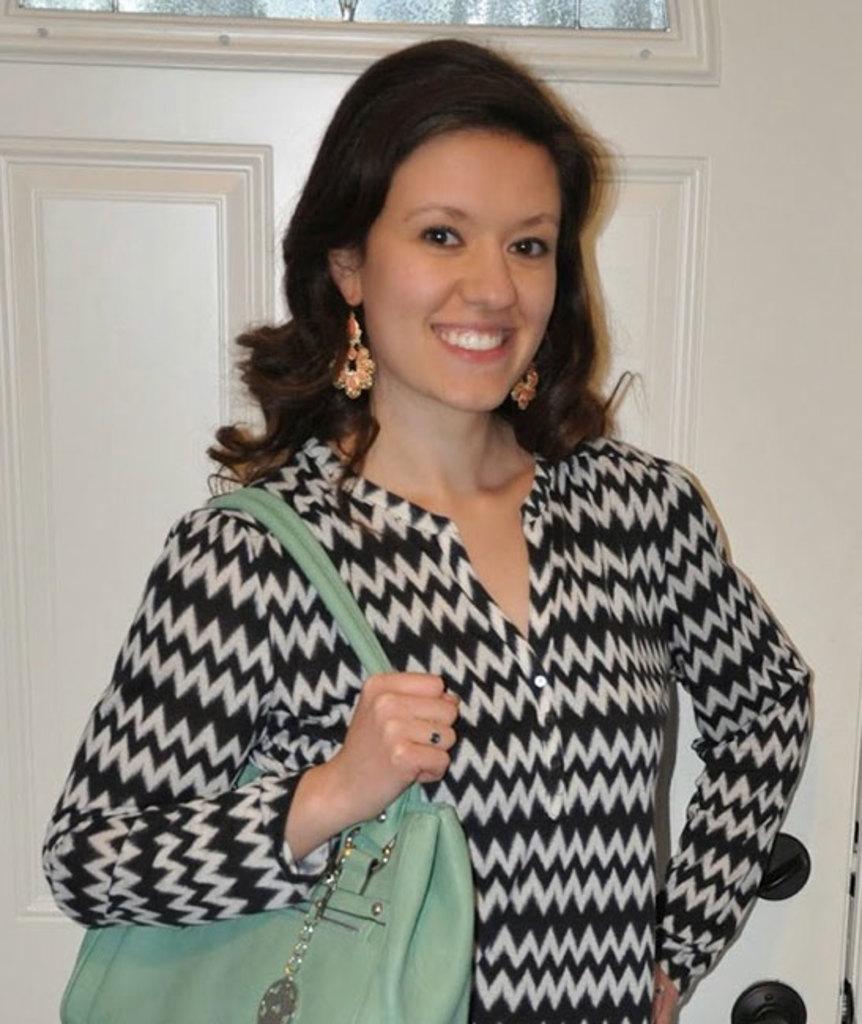Can you describe this image briefly? In the image there is a woman standing in front of a door, she is smiling and she is also wearing a green hand bag. 